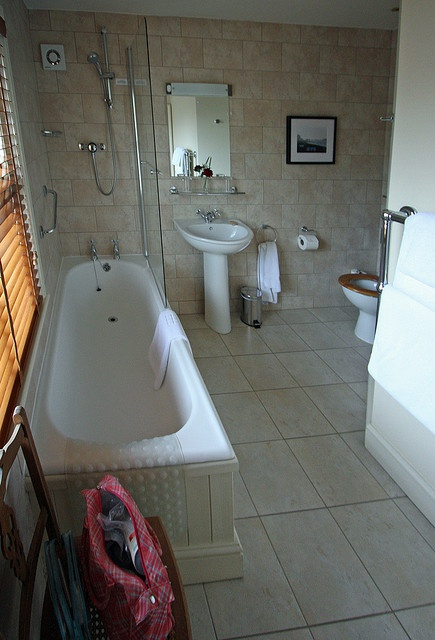Describe the objects in this image and their specific colors. I can see chair in black, gray, and maroon tones, handbag in black, maroon, gray, and purple tones, sink in black, darkgray, and gray tones, and toilet in black, darkgray, maroon, and gray tones in this image. 